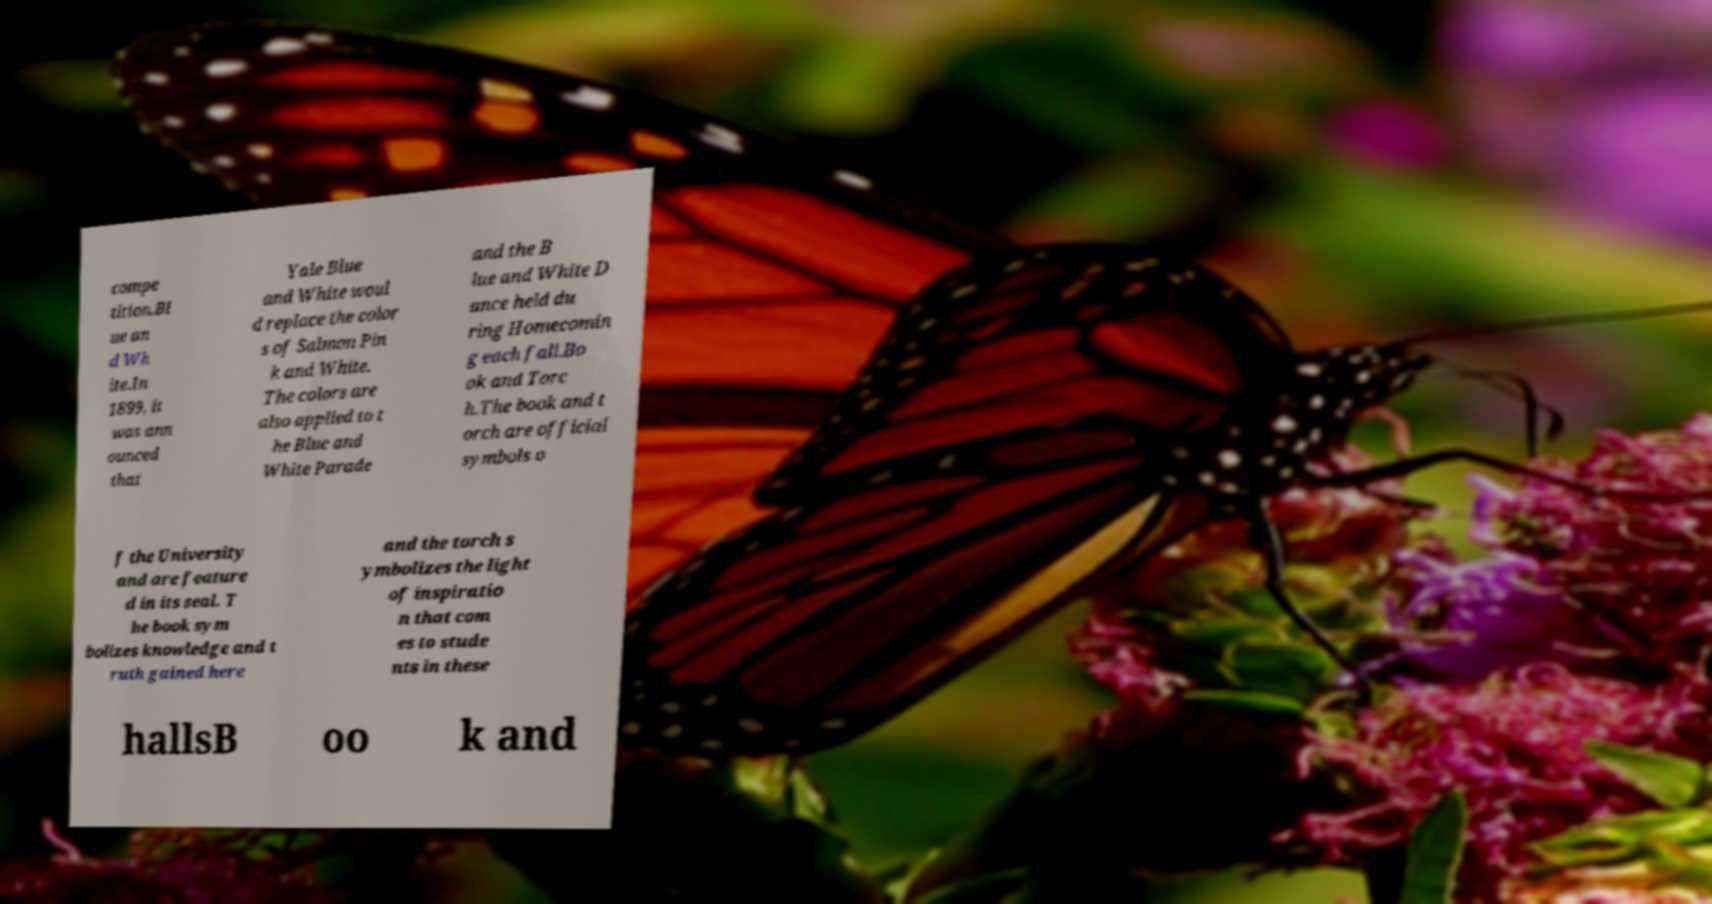Could you extract and type out the text from this image? compe tition.Bl ue an d Wh ite.In 1899, it was ann ounced that Yale Blue and White woul d replace the color s of Salmon Pin k and White. The colors are also applied to t he Blue and White Parade and the B lue and White D ance held du ring Homecomin g each fall.Bo ok and Torc h.The book and t orch are official symbols o f the University and are feature d in its seal. T he book sym bolizes knowledge and t ruth gained here and the torch s ymbolizes the light of inspiratio n that com es to stude nts in these hallsB oo k and 